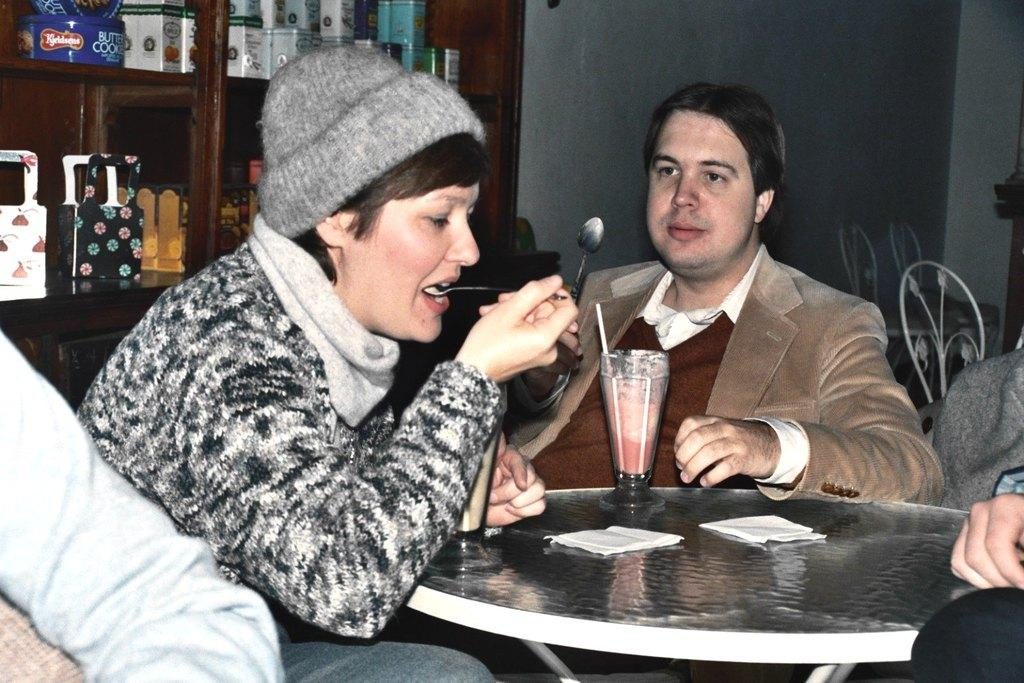What are the people in the image doing? There are persons sitting in front of the table, and one person is eating. What is located at the back of the image? There is a cupboard at the back. Can you describe the contents of the cupboard? There are objects inside the cupboard. What type of sack can be seen hanging from the ceiling in the image? There is no sack hanging from the ceiling in the image. How many family members are present in the image? The provided facts do not mention the number of family members or any familial relationships, so it cannot be determined from the image. 